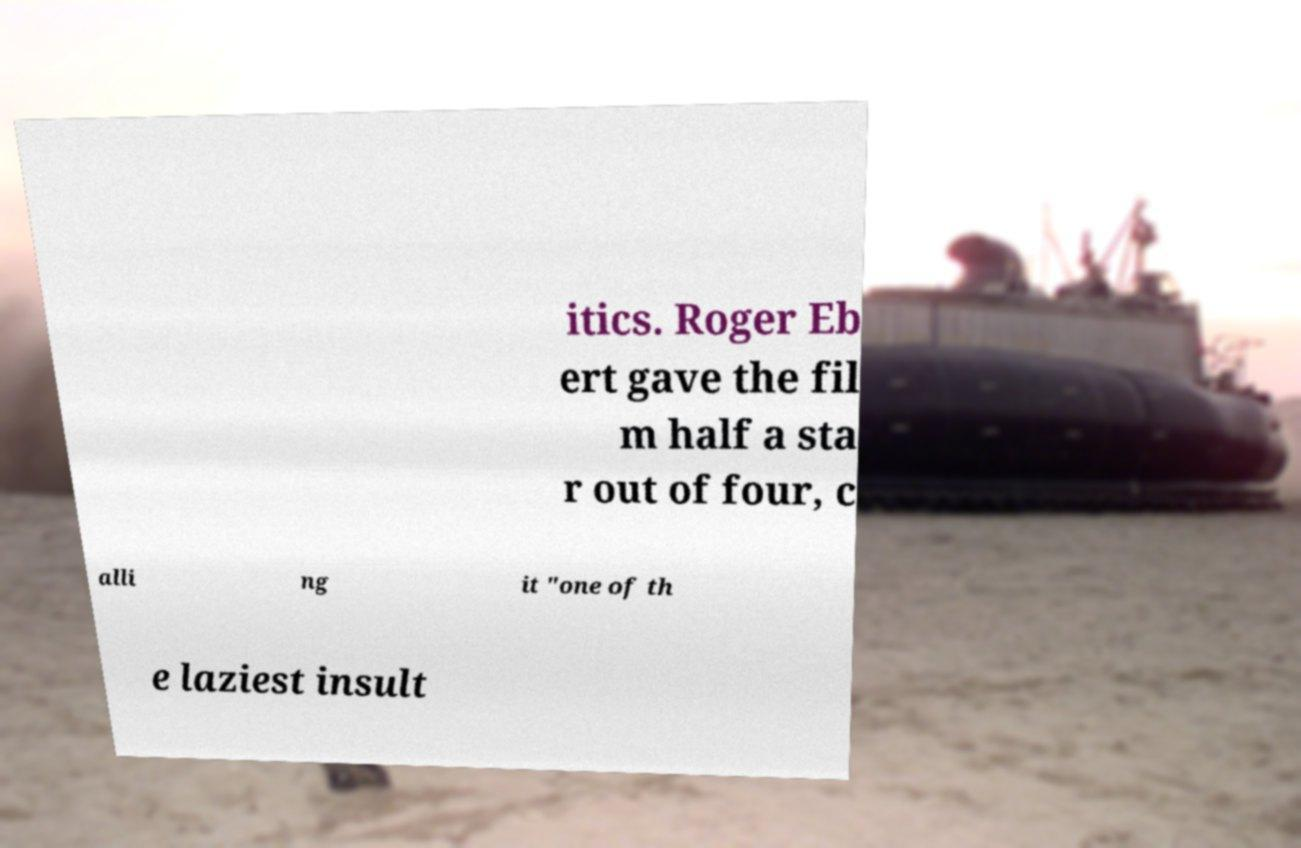What messages or text are displayed in this image? I need them in a readable, typed format. itics. Roger Eb ert gave the fil m half a sta r out of four, c alli ng it "one of th e laziest insult 